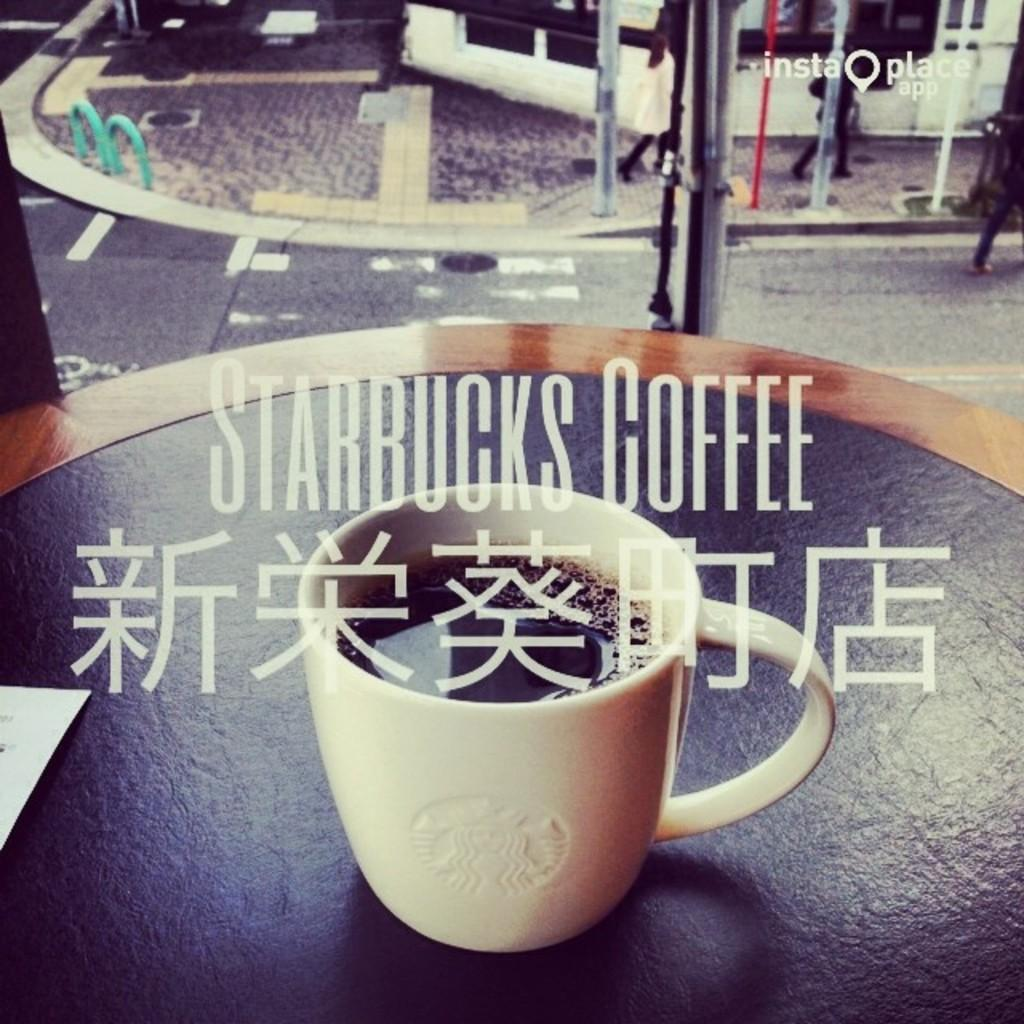What is in the cup that is visible in the image? The cup contains coffee. What brand of coffee is in the cup? The coffee is from Starbucks. Where is the cup placed in the image? The cup is placed on a table. What is written in the right top corner of the image? There is text written in the right top corner of the image. Can you see any farmers working in the fields in the image? There are no farmers or fields visible in the image; it features a cup of coffee from Starbucks. Is there any coal present in the image? There is no coal present in the image. 